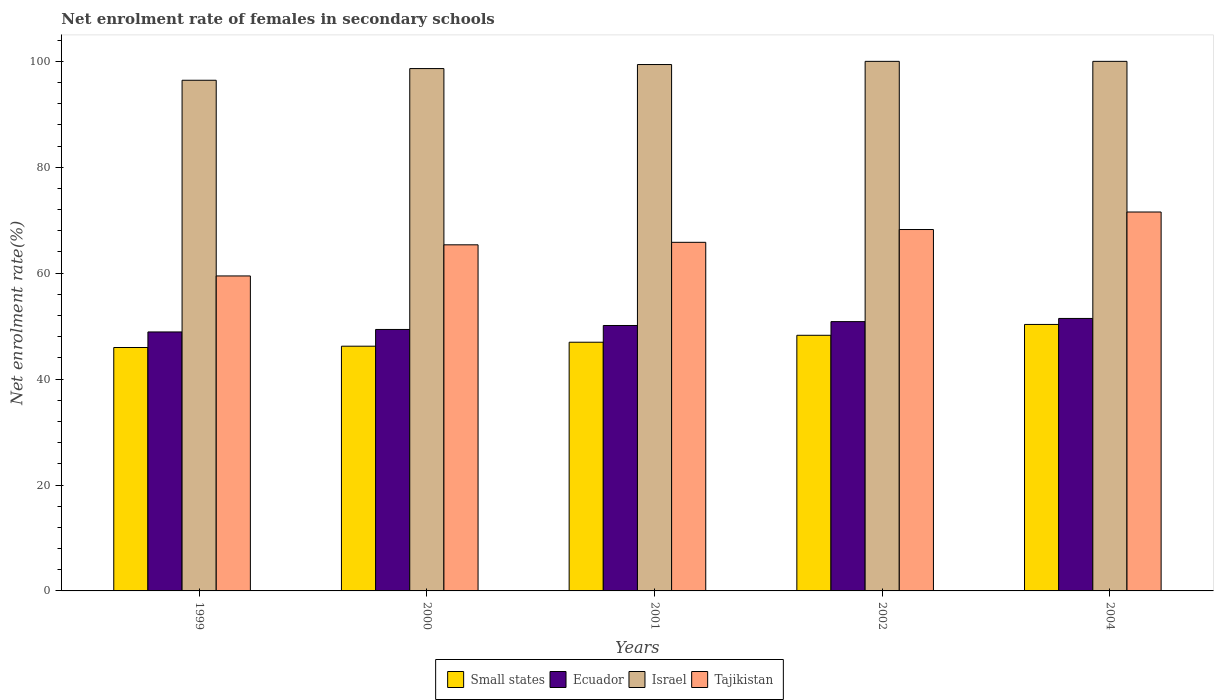How many different coloured bars are there?
Your response must be concise. 4. How many groups of bars are there?
Offer a very short reply. 5. Are the number of bars on each tick of the X-axis equal?
Your answer should be very brief. Yes. How many bars are there on the 4th tick from the left?
Offer a terse response. 4. In how many cases, is the number of bars for a given year not equal to the number of legend labels?
Your answer should be very brief. 0. What is the net enrolment rate of females in secondary schools in Small states in 2004?
Make the answer very short. 50.32. Across all years, what is the minimum net enrolment rate of females in secondary schools in Israel?
Provide a short and direct response. 96.43. In which year was the net enrolment rate of females in secondary schools in Small states minimum?
Your response must be concise. 1999. What is the total net enrolment rate of females in secondary schools in Ecuador in the graph?
Give a very brief answer. 250.7. What is the difference between the net enrolment rate of females in secondary schools in Tajikistan in 2000 and that in 2002?
Your answer should be compact. -2.89. What is the difference between the net enrolment rate of females in secondary schools in Small states in 1999 and the net enrolment rate of females in secondary schools in Ecuador in 2004?
Your answer should be very brief. -5.49. What is the average net enrolment rate of females in secondary schools in Ecuador per year?
Give a very brief answer. 50.14. In the year 2004, what is the difference between the net enrolment rate of females in secondary schools in Tajikistan and net enrolment rate of females in secondary schools in Ecuador?
Offer a terse response. 20.1. What is the ratio of the net enrolment rate of females in secondary schools in Ecuador in 1999 to that in 2001?
Your response must be concise. 0.98. Is the net enrolment rate of females in secondary schools in Israel in 1999 less than that in 2000?
Ensure brevity in your answer.  Yes. What is the difference between the highest and the second highest net enrolment rate of females in secondary schools in Tajikistan?
Keep it short and to the point. 3.31. What is the difference between the highest and the lowest net enrolment rate of females in secondary schools in Israel?
Give a very brief answer. 3.57. What does the 1st bar from the left in 1999 represents?
Offer a very short reply. Small states. What does the 4th bar from the right in 2004 represents?
Keep it short and to the point. Small states. Is it the case that in every year, the sum of the net enrolment rate of females in secondary schools in Israel and net enrolment rate of females in secondary schools in Small states is greater than the net enrolment rate of females in secondary schools in Ecuador?
Your answer should be compact. Yes. How many bars are there?
Make the answer very short. 20. Are the values on the major ticks of Y-axis written in scientific E-notation?
Provide a short and direct response. No. Does the graph contain any zero values?
Your answer should be compact. No. Does the graph contain grids?
Give a very brief answer. No. How many legend labels are there?
Offer a very short reply. 4. How are the legend labels stacked?
Ensure brevity in your answer.  Horizontal. What is the title of the graph?
Make the answer very short. Net enrolment rate of females in secondary schools. What is the label or title of the Y-axis?
Offer a very short reply. Net enrolment rate(%). What is the Net enrolment rate(%) in Small states in 1999?
Your answer should be compact. 45.96. What is the Net enrolment rate(%) of Ecuador in 1999?
Your answer should be compact. 48.9. What is the Net enrolment rate(%) in Israel in 1999?
Your response must be concise. 96.43. What is the Net enrolment rate(%) of Tajikistan in 1999?
Give a very brief answer. 59.48. What is the Net enrolment rate(%) of Small states in 2000?
Offer a terse response. 46.21. What is the Net enrolment rate(%) of Ecuador in 2000?
Give a very brief answer. 49.37. What is the Net enrolment rate(%) in Israel in 2000?
Ensure brevity in your answer.  98.64. What is the Net enrolment rate(%) in Tajikistan in 2000?
Ensure brevity in your answer.  65.36. What is the Net enrolment rate(%) of Small states in 2001?
Your answer should be very brief. 46.96. What is the Net enrolment rate(%) in Ecuador in 2001?
Give a very brief answer. 50.12. What is the Net enrolment rate(%) in Israel in 2001?
Provide a short and direct response. 99.4. What is the Net enrolment rate(%) of Tajikistan in 2001?
Offer a very short reply. 65.83. What is the Net enrolment rate(%) of Small states in 2002?
Offer a very short reply. 48.27. What is the Net enrolment rate(%) in Ecuador in 2002?
Your answer should be very brief. 50.85. What is the Net enrolment rate(%) in Tajikistan in 2002?
Your response must be concise. 68.24. What is the Net enrolment rate(%) of Small states in 2004?
Make the answer very short. 50.32. What is the Net enrolment rate(%) in Ecuador in 2004?
Provide a short and direct response. 51.45. What is the Net enrolment rate(%) of Tajikistan in 2004?
Offer a very short reply. 71.55. Across all years, what is the maximum Net enrolment rate(%) of Small states?
Your response must be concise. 50.32. Across all years, what is the maximum Net enrolment rate(%) in Ecuador?
Ensure brevity in your answer.  51.45. Across all years, what is the maximum Net enrolment rate(%) of Tajikistan?
Your answer should be very brief. 71.55. Across all years, what is the minimum Net enrolment rate(%) in Small states?
Keep it short and to the point. 45.96. Across all years, what is the minimum Net enrolment rate(%) in Ecuador?
Keep it short and to the point. 48.9. Across all years, what is the minimum Net enrolment rate(%) in Israel?
Keep it short and to the point. 96.43. Across all years, what is the minimum Net enrolment rate(%) of Tajikistan?
Your answer should be very brief. 59.48. What is the total Net enrolment rate(%) of Small states in the graph?
Your answer should be compact. 237.73. What is the total Net enrolment rate(%) of Ecuador in the graph?
Provide a succinct answer. 250.7. What is the total Net enrolment rate(%) of Israel in the graph?
Your response must be concise. 494.47. What is the total Net enrolment rate(%) of Tajikistan in the graph?
Ensure brevity in your answer.  330.45. What is the difference between the Net enrolment rate(%) of Small states in 1999 and that in 2000?
Your response must be concise. -0.25. What is the difference between the Net enrolment rate(%) in Ecuador in 1999 and that in 2000?
Your answer should be very brief. -0.47. What is the difference between the Net enrolment rate(%) in Israel in 1999 and that in 2000?
Your answer should be very brief. -2.21. What is the difference between the Net enrolment rate(%) in Tajikistan in 1999 and that in 2000?
Provide a succinct answer. -5.88. What is the difference between the Net enrolment rate(%) in Small states in 1999 and that in 2001?
Ensure brevity in your answer.  -1. What is the difference between the Net enrolment rate(%) of Ecuador in 1999 and that in 2001?
Your answer should be very brief. -1.22. What is the difference between the Net enrolment rate(%) in Israel in 1999 and that in 2001?
Give a very brief answer. -2.97. What is the difference between the Net enrolment rate(%) in Tajikistan in 1999 and that in 2001?
Keep it short and to the point. -6.35. What is the difference between the Net enrolment rate(%) of Small states in 1999 and that in 2002?
Offer a terse response. -2.31. What is the difference between the Net enrolment rate(%) in Ecuador in 1999 and that in 2002?
Offer a terse response. -1.95. What is the difference between the Net enrolment rate(%) of Israel in 1999 and that in 2002?
Ensure brevity in your answer.  -3.57. What is the difference between the Net enrolment rate(%) of Tajikistan in 1999 and that in 2002?
Ensure brevity in your answer.  -8.77. What is the difference between the Net enrolment rate(%) of Small states in 1999 and that in 2004?
Ensure brevity in your answer.  -4.35. What is the difference between the Net enrolment rate(%) of Ecuador in 1999 and that in 2004?
Keep it short and to the point. -2.55. What is the difference between the Net enrolment rate(%) in Israel in 1999 and that in 2004?
Keep it short and to the point. -3.57. What is the difference between the Net enrolment rate(%) of Tajikistan in 1999 and that in 2004?
Your answer should be very brief. -12.07. What is the difference between the Net enrolment rate(%) of Small states in 2000 and that in 2001?
Provide a short and direct response. -0.75. What is the difference between the Net enrolment rate(%) in Ecuador in 2000 and that in 2001?
Offer a very short reply. -0.75. What is the difference between the Net enrolment rate(%) in Israel in 2000 and that in 2001?
Offer a terse response. -0.76. What is the difference between the Net enrolment rate(%) of Tajikistan in 2000 and that in 2001?
Give a very brief answer. -0.47. What is the difference between the Net enrolment rate(%) of Small states in 2000 and that in 2002?
Ensure brevity in your answer.  -2.06. What is the difference between the Net enrolment rate(%) of Ecuador in 2000 and that in 2002?
Offer a very short reply. -1.48. What is the difference between the Net enrolment rate(%) in Israel in 2000 and that in 2002?
Your answer should be very brief. -1.36. What is the difference between the Net enrolment rate(%) of Tajikistan in 2000 and that in 2002?
Keep it short and to the point. -2.89. What is the difference between the Net enrolment rate(%) of Small states in 2000 and that in 2004?
Ensure brevity in your answer.  -4.11. What is the difference between the Net enrolment rate(%) in Ecuador in 2000 and that in 2004?
Ensure brevity in your answer.  -2.08. What is the difference between the Net enrolment rate(%) in Israel in 2000 and that in 2004?
Make the answer very short. -1.36. What is the difference between the Net enrolment rate(%) of Tajikistan in 2000 and that in 2004?
Keep it short and to the point. -6.2. What is the difference between the Net enrolment rate(%) in Small states in 2001 and that in 2002?
Your answer should be very brief. -1.31. What is the difference between the Net enrolment rate(%) in Ecuador in 2001 and that in 2002?
Provide a succinct answer. -0.73. What is the difference between the Net enrolment rate(%) of Israel in 2001 and that in 2002?
Offer a very short reply. -0.6. What is the difference between the Net enrolment rate(%) in Tajikistan in 2001 and that in 2002?
Keep it short and to the point. -2.42. What is the difference between the Net enrolment rate(%) in Small states in 2001 and that in 2004?
Offer a very short reply. -3.36. What is the difference between the Net enrolment rate(%) in Ecuador in 2001 and that in 2004?
Give a very brief answer. -1.33. What is the difference between the Net enrolment rate(%) of Israel in 2001 and that in 2004?
Offer a terse response. -0.6. What is the difference between the Net enrolment rate(%) in Tajikistan in 2001 and that in 2004?
Make the answer very short. -5.72. What is the difference between the Net enrolment rate(%) of Small states in 2002 and that in 2004?
Your answer should be compact. -2.05. What is the difference between the Net enrolment rate(%) of Ecuador in 2002 and that in 2004?
Offer a very short reply. -0.6. What is the difference between the Net enrolment rate(%) in Tajikistan in 2002 and that in 2004?
Your answer should be compact. -3.31. What is the difference between the Net enrolment rate(%) of Small states in 1999 and the Net enrolment rate(%) of Ecuador in 2000?
Keep it short and to the point. -3.41. What is the difference between the Net enrolment rate(%) in Small states in 1999 and the Net enrolment rate(%) in Israel in 2000?
Provide a short and direct response. -52.67. What is the difference between the Net enrolment rate(%) of Small states in 1999 and the Net enrolment rate(%) of Tajikistan in 2000?
Your response must be concise. -19.39. What is the difference between the Net enrolment rate(%) of Ecuador in 1999 and the Net enrolment rate(%) of Israel in 2000?
Your answer should be very brief. -49.74. What is the difference between the Net enrolment rate(%) in Ecuador in 1999 and the Net enrolment rate(%) in Tajikistan in 2000?
Provide a succinct answer. -16.45. What is the difference between the Net enrolment rate(%) in Israel in 1999 and the Net enrolment rate(%) in Tajikistan in 2000?
Provide a succinct answer. 31.07. What is the difference between the Net enrolment rate(%) of Small states in 1999 and the Net enrolment rate(%) of Ecuador in 2001?
Provide a succinct answer. -4.16. What is the difference between the Net enrolment rate(%) of Small states in 1999 and the Net enrolment rate(%) of Israel in 2001?
Keep it short and to the point. -53.43. What is the difference between the Net enrolment rate(%) of Small states in 1999 and the Net enrolment rate(%) of Tajikistan in 2001?
Provide a succinct answer. -19.86. What is the difference between the Net enrolment rate(%) of Ecuador in 1999 and the Net enrolment rate(%) of Israel in 2001?
Give a very brief answer. -50.5. What is the difference between the Net enrolment rate(%) of Ecuador in 1999 and the Net enrolment rate(%) of Tajikistan in 2001?
Give a very brief answer. -16.92. What is the difference between the Net enrolment rate(%) of Israel in 1999 and the Net enrolment rate(%) of Tajikistan in 2001?
Offer a terse response. 30.6. What is the difference between the Net enrolment rate(%) in Small states in 1999 and the Net enrolment rate(%) in Ecuador in 2002?
Offer a terse response. -4.89. What is the difference between the Net enrolment rate(%) in Small states in 1999 and the Net enrolment rate(%) in Israel in 2002?
Provide a short and direct response. -54.04. What is the difference between the Net enrolment rate(%) in Small states in 1999 and the Net enrolment rate(%) in Tajikistan in 2002?
Offer a terse response. -22.28. What is the difference between the Net enrolment rate(%) in Ecuador in 1999 and the Net enrolment rate(%) in Israel in 2002?
Make the answer very short. -51.1. What is the difference between the Net enrolment rate(%) in Ecuador in 1999 and the Net enrolment rate(%) in Tajikistan in 2002?
Ensure brevity in your answer.  -19.34. What is the difference between the Net enrolment rate(%) in Israel in 1999 and the Net enrolment rate(%) in Tajikistan in 2002?
Ensure brevity in your answer.  28.19. What is the difference between the Net enrolment rate(%) in Small states in 1999 and the Net enrolment rate(%) in Ecuador in 2004?
Give a very brief answer. -5.49. What is the difference between the Net enrolment rate(%) of Small states in 1999 and the Net enrolment rate(%) of Israel in 2004?
Keep it short and to the point. -54.04. What is the difference between the Net enrolment rate(%) of Small states in 1999 and the Net enrolment rate(%) of Tajikistan in 2004?
Your response must be concise. -25.59. What is the difference between the Net enrolment rate(%) in Ecuador in 1999 and the Net enrolment rate(%) in Israel in 2004?
Give a very brief answer. -51.1. What is the difference between the Net enrolment rate(%) of Ecuador in 1999 and the Net enrolment rate(%) of Tajikistan in 2004?
Keep it short and to the point. -22.65. What is the difference between the Net enrolment rate(%) of Israel in 1999 and the Net enrolment rate(%) of Tajikistan in 2004?
Offer a terse response. 24.88. What is the difference between the Net enrolment rate(%) in Small states in 2000 and the Net enrolment rate(%) in Ecuador in 2001?
Your response must be concise. -3.91. What is the difference between the Net enrolment rate(%) in Small states in 2000 and the Net enrolment rate(%) in Israel in 2001?
Give a very brief answer. -53.19. What is the difference between the Net enrolment rate(%) in Small states in 2000 and the Net enrolment rate(%) in Tajikistan in 2001?
Your answer should be compact. -19.62. What is the difference between the Net enrolment rate(%) of Ecuador in 2000 and the Net enrolment rate(%) of Israel in 2001?
Give a very brief answer. -50.03. What is the difference between the Net enrolment rate(%) in Ecuador in 2000 and the Net enrolment rate(%) in Tajikistan in 2001?
Provide a succinct answer. -16.45. What is the difference between the Net enrolment rate(%) in Israel in 2000 and the Net enrolment rate(%) in Tajikistan in 2001?
Make the answer very short. 32.81. What is the difference between the Net enrolment rate(%) in Small states in 2000 and the Net enrolment rate(%) in Ecuador in 2002?
Give a very brief answer. -4.64. What is the difference between the Net enrolment rate(%) of Small states in 2000 and the Net enrolment rate(%) of Israel in 2002?
Make the answer very short. -53.79. What is the difference between the Net enrolment rate(%) in Small states in 2000 and the Net enrolment rate(%) in Tajikistan in 2002?
Give a very brief answer. -22.03. What is the difference between the Net enrolment rate(%) of Ecuador in 2000 and the Net enrolment rate(%) of Israel in 2002?
Make the answer very short. -50.63. What is the difference between the Net enrolment rate(%) of Ecuador in 2000 and the Net enrolment rate(%) of Tajikistan in 2002?
Give a very brief answer. -18.87. What is the difference between the Net enrolment rate(%) in Israel in 2000 and the Net enrolment rate(%) in Tajikistan in 2002?
Your answer should be compact. 30.39. What is the difference between the Net enrolment rate(%) of Small states in 2000 and the Net enrolment rate(%) of Ecuador in 2004?
Offer a very short reply. -5.24. What is the difference between the Net enrolment rate(%) of Small states in 2000 and the Net enrolment rate(%) of Israel in 2004?
Ensure brevity in your answer.  -53.79. What is the difference between the Net enrolment rate(%) in Small states in 2000 and the Net enrolment rate(%) in Tajikistan in 2004?
Your response must be concise. -25.34. What is the difference between the Net enrolment rate(%) in Ecuador in 2000 and the Net enrolment rate(%) in Israel in 2004?
Your answer should be compact. -50.63. What is the difference between the Net enrolment rate(%) of Ecuador in 2000 and the Net enrolment rate(%) of Tajikistan in 2004?
Make the answer very short. -22.18. What is the difference between the Net enrolment rate(%) of Israel in 2000 and the Net enrolment rate(%) of Tajikistan in 2004?
Your answer should be compact. 27.09. What is the difference between the Net enrolment rate(%) of Small states in 2001 and the Net enrolment rate(%) of Ecuador in 2002?
Offer a terse response. -3.89. What is the difference between the Net enrolment rate(%) in Small states in 2001 and the Net enrolment rate(%) in Israel in 2002?
Offer a terse response. -53.04. What is the difference between the Net enrolment rate(%) of Small states in 2001 and the Net enrolment rate(%) of Tajikistan in 2002?
Provide a succinct answer. -21.28. What is the difference between the Net enrolment rate(%) in Ecuador in 2001 and the Net enrolment rate(%) in Israel in 2002?
Provide a short and direct response. -49.88. What is the difference between the Net enrolment rate(%) of Ecuador in 2001 and the Net enrolment rate(%) of Tajikistan in 2002?
Make the answer very short. -18.12. What is the difference between the Net enrolment rate(%) in Israel in 2001 and the Net enrolment rate(%) in Tajikistan in 2002?
Provide a short and direct response. 31.16. What is the difference between the Net enrolment rate(%) in Small states in 2001 and the Net enrolment rate(%) in Ecuador in 2004?
Ensure brevity in your answer.  -4.49. What is the difference between the Net enrolment rate(%) in Small states in 2001 and the Net enrolment rate(%) in Israel in 2004?
Ensure brevity in your answer.  -53.04. What is the difference between the Net enrolment rate(%) of Small states in 2001 and the Net enrolment rate(%) of Tajikistan in 2004?
Ensure brevity in your answer.  -24.59. What is the difference between the Net enrolment rate(%) in Ecuador in 2001 and the Net enrolment rate(%) in Israel in 2004?
Your answer should be compact. -49.88. What is the difference between the Net enrolment rate(%) in Ecuador in 2001 and the Net enrolment rate(%) in Tajikistan in 2004?
Offer a very short reply. -21.43. What is the difference between the Net enrolment rate(%) of Israel in 2001 and the Net enrolment rate(%) of Tajikistan in 2004?
Your answer should be very brief. 27.85. What is the difference between the Net enrolment rate(%) in Small states in 2002 and the Net enrolment rate(%) in Ecuador in 2004?
Offer a terse response. -3.18. What is the difference between the Net enrolment rate(%) in Small states in 2002 and the Net enrolment rate(%) in Israel in 2004?
Give a very brief answer. -51.73. What is the difference between the Net enrolment rate(%) of Small states in 2002 and the Net enrolment rate(%) of Tajikistan in 2004?
Provide a succinct answer. -23.28. What is the difference between the Net enrolment rate(%) in Ecuador in 2002 and the Net enrolment rate(%) in Israel in 2004?
Ensure brevity in your answer.  -49.15. What is the difference between the Net enrolment rate(%) of Ecuador in 2002 and the Net enrolment rate(%) of Tajikistan in 2004?
Offer a very short reply. -20.7. What is the difference between the Net enrolment rate(%) in Israel in 2002 and the Net enrolment rate(%) in Tajikistan in 2004?
Your answer should be very brief. 28.45. What is the average Net enrolment rate(%) in Small states per year?
Your response must be concise. 47.55. What is the average Net enrolment rate(%) of Ecuador per year?
Ensure brevity in your answer.  50.14. What is the average Net enrolment rate(%) in Israel per year?
Offer a very short reply. 98.89. What is the average Net enrolment rate(%) of Tajikistan per year?
Ensure brevity in your answer.  66.09. In the year 1999, what is the difference between the Net enrolment rate(%) of Small states and Net enrolment rate(%) of Ecuador?
Your response must be concise. -2.94. In the year 1999, what is the difference between the Net enrolment rate(%) of Small states and Net enrolment rate(%) of Israel?
Offer a terse response. -50.47. In the year 1999, what is the difference between the Net enrolment rate(%) in Small states and Net enrolment rate(%) in Tajikistan?
Ensure brevity in your answer.  -13.51. In the year 1999, what is the difference between the Net enrolment rate(%) in Ecuador and Net enrolment rate(%) in Israel?
Keep it short and to the point. -47.53. In the year 1999, what is the difference between the Net enrolment rate(%) in Ecuador and Net enrolment rate(%) in Tajikistan?
Your answer should be compact. -10.58. In the year 1999, what is the difference between the Net enrolment rate(%) of Israel and Net enrolment rate(%) of Tajikistan?
Offer a very short reply. 36.95. In the year 2000, what is the difference between the Net enrolment rate(%) of Small states and Net enrolment rate(%) of Ecuador?
Ensure brevity in your answer.  -3.16. In the year 2000, what is the difference between the Net enrolment rate(%) of Small states and Net enrolment rate(%) of Israel?
Give a very brief answer. -52.43. In the year 2000, what is the difference between the Net enrolment rate(%) in Small states and Net enrolment rate(%) in Tajikistan?
Your response must be concise. -19.14. In the year 2000, what is the difference between the Net enrolment rate(%) of Ecuador and Net enrolment rate(%) of Israel?
Offer a terse response. -49.27. In the year 2000, what is the difference between the Net enrolment rate(%) of Ecuador and Net enrolment rate(%) of Tajikistan?
Offer a terse response. -15.98. In the year 2000, what is the difference between the Net enrolment rate(%) of Israel and Net enrolment rate(%) of Tajikistan?
Keep it short and to the point. 33.28. In the year 2001, what is the difference between the Net enrolment rate(%) in Small states and Net enrolment rate(%) in Ecuador?
Ensure brevity in your answer.  -3.16. In the year 2001, what is the difference between the Net enrolment rate(%) in Small states and Net enrolment rate(%) in Israel?
Ensure brevity in your answer.  -52.44. In the year 2001, what is the difference between the Net enrolment rate(%) of Small states and Net enrolment rate(%) of Tajikistan?
Your answer should be very brief. -18.86. In the year 2001, what is the difference between the Net enrolment rate(%) in Ecuador and Net enrolment rate(%) in Israel?
Give a very brief answer. -49.28. In the year 2001, what is the difference between the Net enrolment rate(%) of Ecuador and Net enrolment rate(%) of Tajikistan?
Your answer should be compact. -15.7. In the year 2001, what is the difference between the Net enrolment rate(%) of Israel and Net enrolment rate(%) of Tajikistan?
Offer a terse response. 33.57. In the year 2002, what is the difference between the Net enrolment rate(%) of Small states and Net enrolment rate(%) of Ecuador?
Your response must be concise. -2.58. In the year 2002, what is the difference between the Net enrolment rate(%) in Small states and Net enrolment rate(%) in Israel?
Give a very brief answer. -51.73. In the year 2002, what is the difference between the Net enrolment rate(%) in Small states and Net enrolment rate(%) in Tajikistan?
Keep it short and to the point. -19.97. In the year 2002, what is the difference between the Net enrolment rate(%) in Ecuador and Net enrolment rate(%) in Israel?
Keep it short and to the point. -49.15. In the year 2002, what is the difference between the Net enrolment rate(%) in Ecuador and Net enrolment rate(%) in Tajikistan?
Offer a terse response. -17.39. In the year 2002, what is the difference between the Net enrolment rate(%) in Israel and Net enrolment rate(%) in Tajikistan?
Ensure brevity in your answer.  31.76. In the year 2004, what is the difference between the Net enrolment rate(%) in Small states and Net enrolment rate(%) in Ecuador?
Keep it short and to the point. -1.13. In the year 2004, what is the difference between the Net enrolment rate(%) in Small states and Net enrolment rate(%) in Israel?
Offer a terse response. -49.68. In the year 2004, what is the difference between the Net enrolment rate(%) of Small states and Net enrolment rate(%) of Tajikistan?
Make the answer very short. -21.23. In the year 2004, what is the difference between the Net enrolment rate(%) in Ecuador and Net enrolment rate(%) in Israel?
Your response must be concise. -48.55. In the year 2004, what is the difference between the Net enrolment rate(%) of Ecuador and Net enrolment rate(%) of Tajikistan?
Provide a short and direct response. -20.1. In the year 2004, what is the difference between the Net enrolment rate(%) of Israel and Net enrolment rate(%) of Tajikistan?
Keep it short and to the point. 28.45. What is the ratio of the Net enrolment rate(%) of Israel in 1999 to that in 2000?
Give a very brief answer. 0.98. What is the ratio of the Net enrolment rate(%) in Tajikistan in 1999 to that in 2000?
Ensure brevity in your answer.  0.91. What is the ratio of the Net enrolment rate(%) of Small states in 1999 to that in 2001?
Make the answer very short. 0.98. What is the ratio of the Net enrolment rate(%) in Ecuador in 1999 to that in 2001?
Make the answer very short. 0.98. What is the ratio of the Net enrolment rate(%) of Israel in 1999 to that in 2001?
Ensure brevity in your answer.  0.97. What is the ratio of the Net enrolment rate(%) of Tajikistan in 1999 to that in 2001?
Provide a short and direct response. 0.9. What is the ratio of the Net enrolment rate(%) of Small states in 1999 to that in 2002?
Make the answer very short. 0.95. What is the ratio of the Net enrolment rate(%) in Ecuador in 1999 to that in 2002?
Your response must be concise. 0.96. What is the ratio of the Net enrolment rate(%) in Tajikistan in 1999 to that in 2002?
Your response must be concise. 0.87. What is the ratio of the Net enrolment rate(%) of Small states in 1999 to that in 2004?
Your answer should be compact. 0.91. What is the ratio of the Net enrolment rate(%) in Ecuador in 1999 to that in 2004?
Your answer should be very brief. 0.95. What is the ratio of the Net enrolment rate(%) in Tajikistan in 1999 to that in 2004?
Make the answer very short. 0.83. What is the ratio of the Net enrolment rate(%) of Tajikistan in 2000 to that in 2001?
Provide a short and direct response. 0.99. What is the ratio of the Net enrolment rate(%) of Small states in 2000 to that in 2002?
Your answer should be very brief. 0.96. What is the ratio of the Net enrolment rate(%) of Ecuador in 2000 to that in 2002?
Keep it short and to the point. 0.97. What is the ratio of the Net enrolment rate(%) of Israel in 2000 to that in 2002?
Ensure brevity in your answer.  0.99. What is the ratio of the Net enrolment rate(%) in Tajikistan in 2000 to that in 2002?
Provide a succinct answer. 0.96. What is the ratio of the Net enrolment rate(%) of Small states in 2000 to that in 2004?
Your response must be concise. 0.92. What is the ratio of the Net enrolment rate(%) in Ecuador in 2000 to that in 2004?
Your answer should be very brief. 0.96. What is the ratio of the Net enrolment rate(%) in Israel in 2000 to that in 2004?
Provide a short and direct response. 0.99. What is the ratio of the Net enrolment rate(%) in Tajikistan in 2000 to that in 2004?
Your answer should be compact. 0.91. What is the ratio of the Net enrolment rate(%) in Small states in 2001 to that in 2002?
Your response must be concise. 0.97. What is the ratio of the Net enrolment rate(%) of Ecuador in 2001 to that in 2002?
Provide a short and direct response. 0.99. What is the ratio of the Net enrolment rate(%) of Israel in 2001 to that in 2002?
Give a very brief answer. 0.99. What is the ratio of the Net enrolment rate(%) of Tajikistan in 2001 to that in 2002?
Provide a succinct answer. 0.96. What is the ratio of the Net enrolment rate(%) of Small states in 2001 to that in 2004?
Offer a very short reply. 0.93. What is the ratio of the Net enrolment rate(%) of Ecuador in 2001 to that in 2004?
Offer a terse response. 0.97. What is the ratio of the Net enrolment rate(%) of Tajikistan in 2001 to that in 2004?
Offer a terse response. 0.92. What is the ratio of the Net enrolment rate(%) of Small states in 2002 to that in 2004?
Provide a succinct answer. 0.96. What is the ratio of the Net enrolment rate(%) of Ecuador in 2002 to that in 2004?
Offer a terse response. 0.99. What is the ratio of the Net enrolment rate(%) of Israel in 2002 to that in 2004?
Offer a very short reply. 1. What is the ratio of the Net enrolment rate(%) in Tajikistan in 2002 to that in 2004?
Give a very brief answer. 0.95. What is the difference between the highest and the second highest Net enrolment rate(%) of Small states?
Provide a succinct answer. 2.05. What is the difference between the highest and the second highest Net enrolment rate(%) in Ecuador?
Provide a succinct answer. 0.6. What is the difference between the highest and the second highest Net enrolment rate(%) of Tajikistan?
Offer a very short reply. 3.31. What is the difference between the highest and the lowest Net enrolment rate(%) of Small states?
Give a very brief answer. 4.35. What is the difference between the highest and the lowest Net enrolment rate(%) in Ecuador?
Your answer should be compact. 2.55. What is the difference between the highest and the lowest Net enrolment rate(%) of Israel?
Offer a terse response. 3.57. What is the difference between the highest and the lowest Net enrolment rate(%) in Tajikistan?
Offer a very short reply. 12.07. 